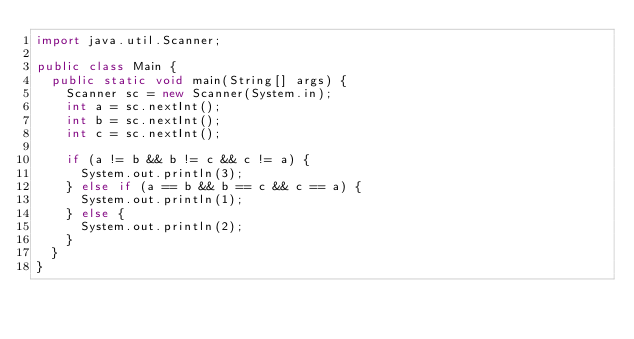<code> <loc_0><loc_0><loc_500><loc_500><_Java_>import java.util.Scanner;

public class Main {
  public static void main(String[] args) {
    Scanner sc = new Scanner(System.in);
    int a = sc.nextInt();
    int b = sc.nextInt();
    int c = sc.nextInt();

    if (a != b && b != c && c != a) {
      System.out.println(3);
    } else if (a == b && b == c && c == a) {
      System.out.println(1);
    } else {
      System.out.println(2);
    }
  }
}
</code> 